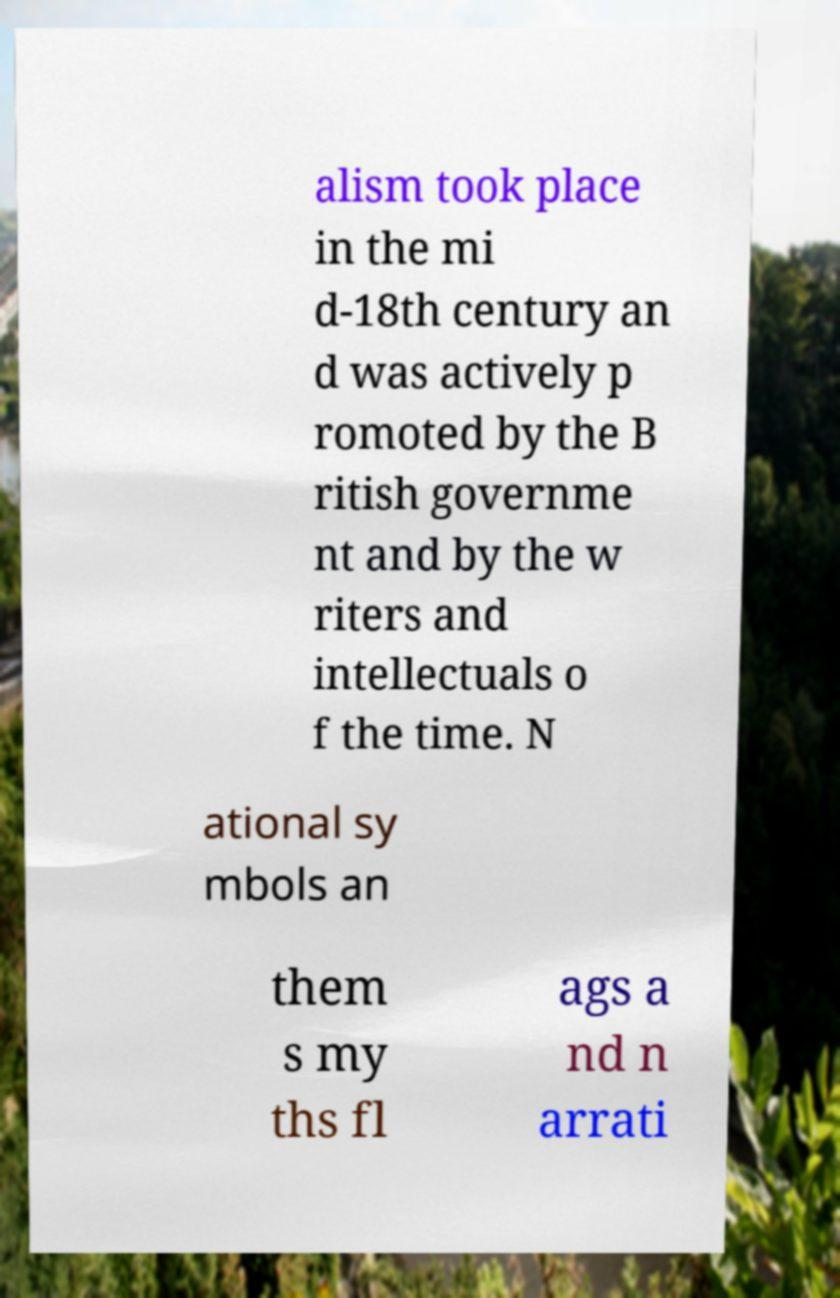There's text embedded in this image that I need extracted. Can you transcribe it verbatim? alism took place in the mi d-18th century an d was actively p romoted by the B ritish governme nt and by the w riters and intellectuals o f the time. N ational sy mbols an them s my ths fl ags a nd n arrati 